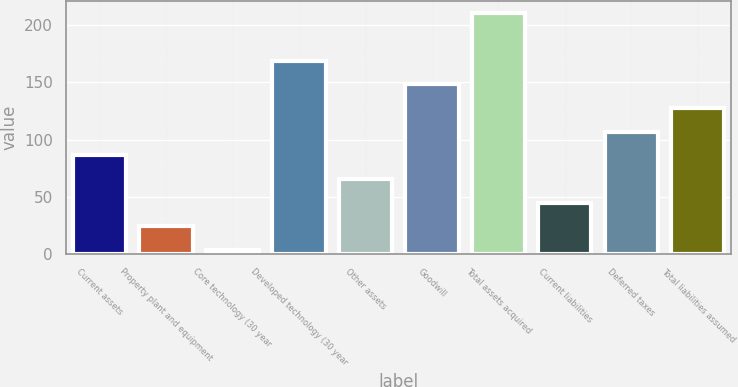Convert chart. <chart><loc_0><loc_0><loc_500><loc_500><bar_chart><fcel>Current assets<fcel>Property plant and equipment<fcel>Core technology (30 year<fcel>Developed technology (30 year<fcel>Other assets<fcel>Goodwill<fcel>Total assets acquired<fcel>Current liabilities<fcel>Deferred taxes<fcel>Total liabilities assumed<nl><fcel>86.36<fcel>24.29<fcel>3.6<fcel>169.12<fcel>65.67<fcel>148.43<fcel>210.5<fcel>44.98<fcel>107.05<fcel>127.74<nl></chart> 